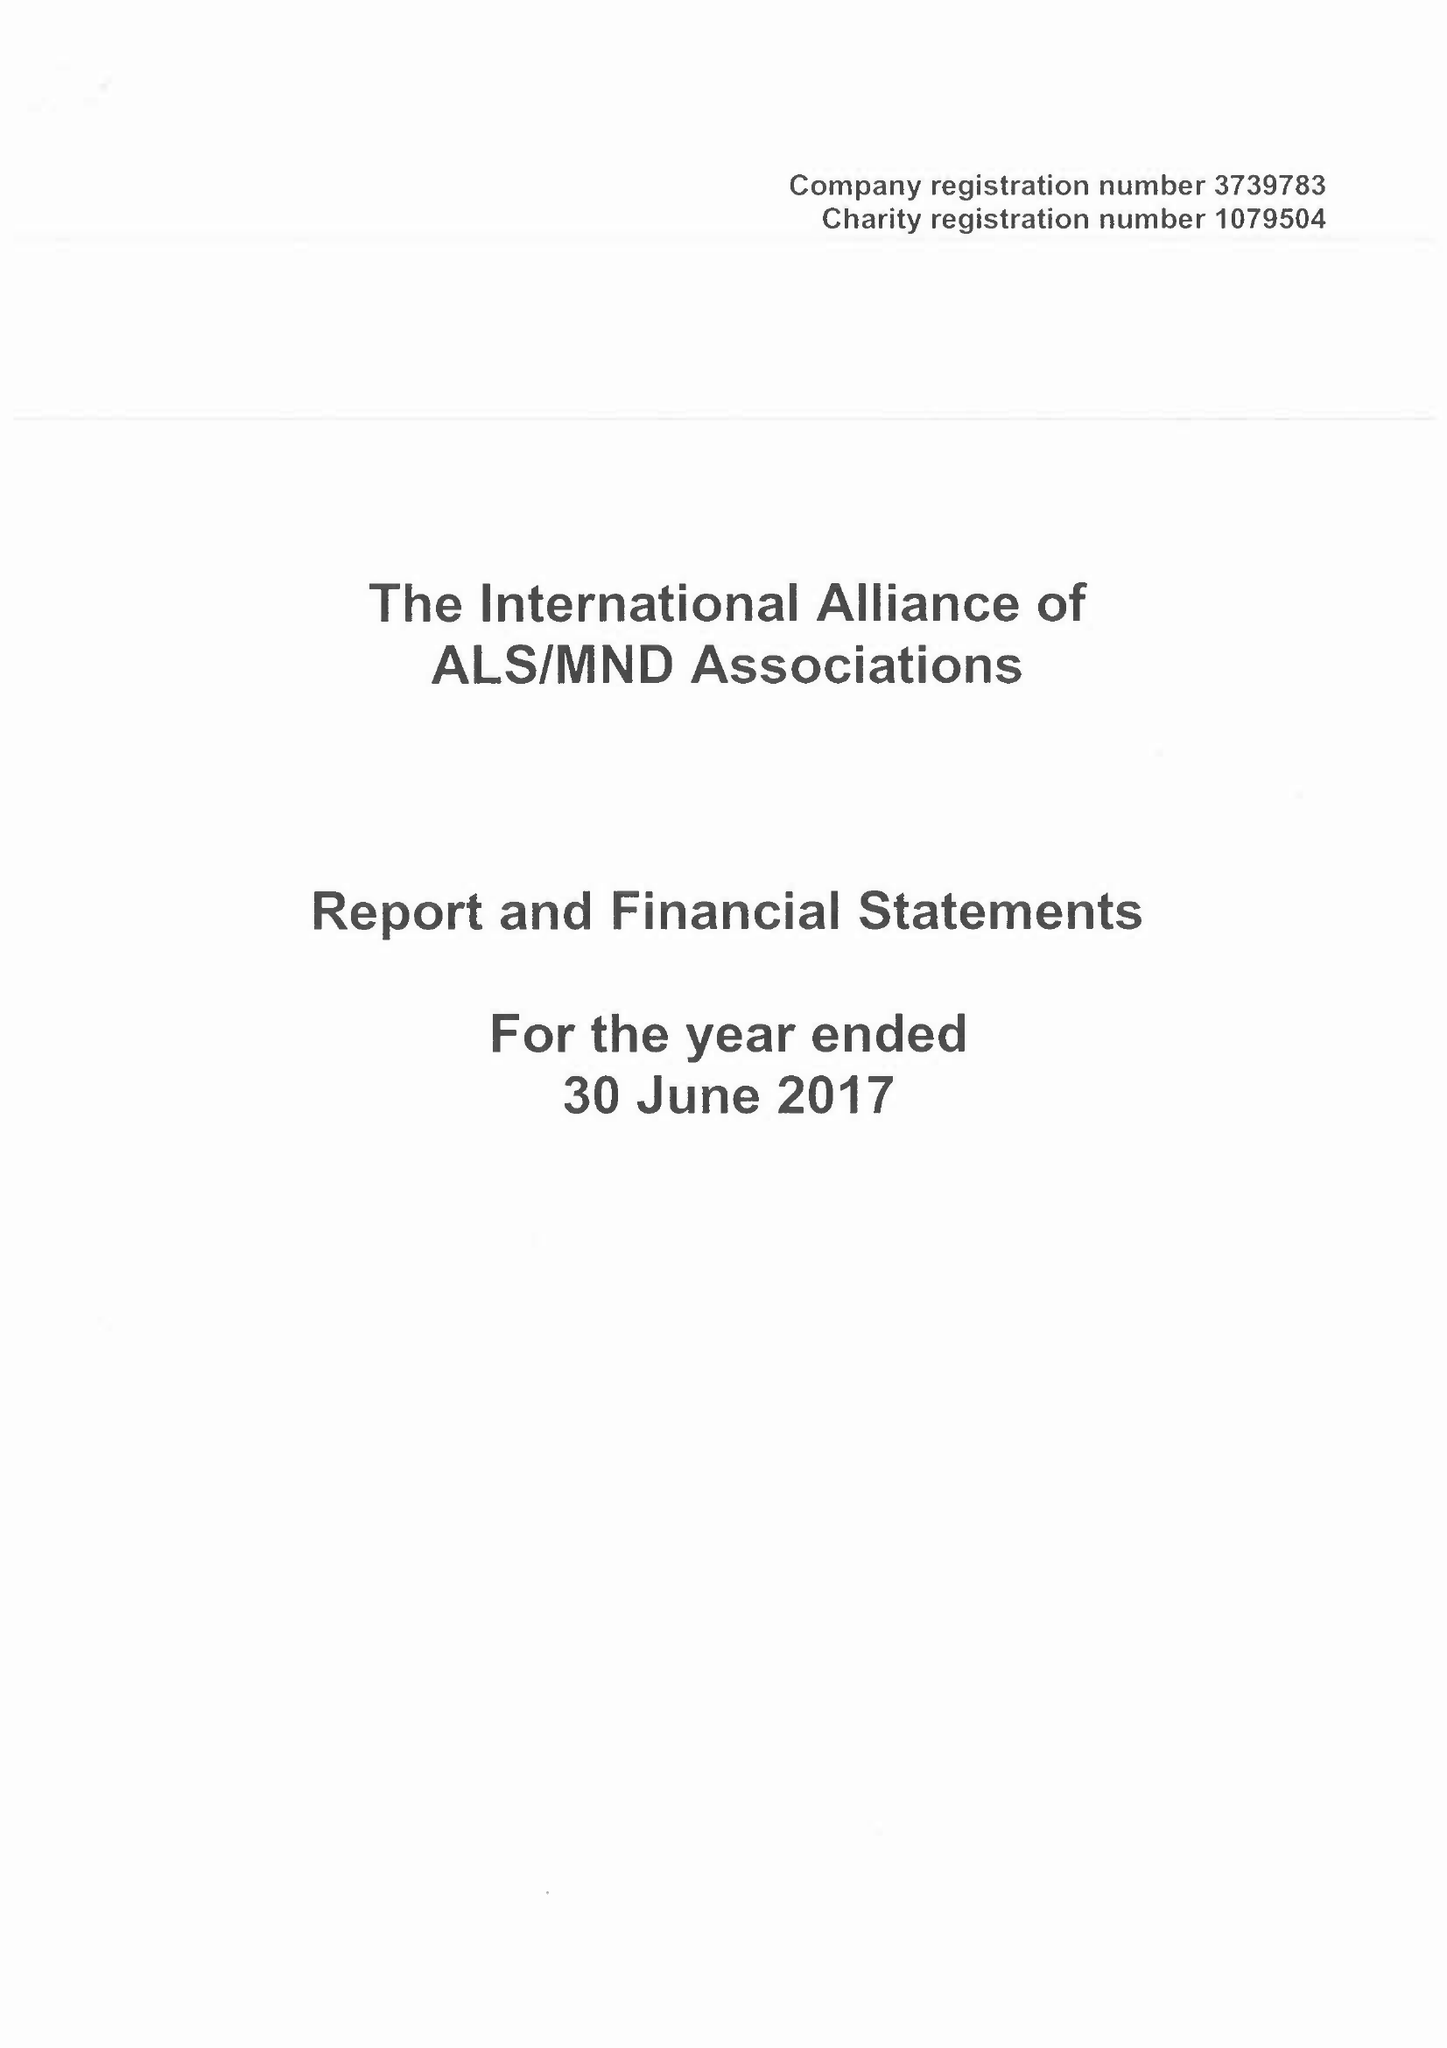What is the value for the spending_annually_in_british_pounds?
Answer the question using a single word or phrase. 146470.00 